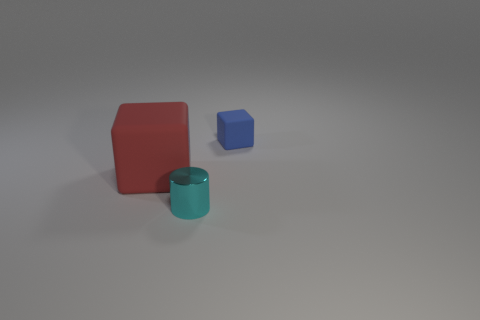Subtract all blue blocks. How many blocks are left? 1 Add 1 tiny cyan objects. How many tiny cyan objects are left? 2 Add 2 blue rubber objects. How many blue rubber objects exist? 3 Add 3 tiny green metallic blocks. How many objects exist? 6 Subtract 0 green blocks. How many objects are left? 3 Subtract all blocks. How many objects are left? 1 Subtract 2 blocks. How many blocks are left? 0 Subtract all yellow cylinders. Subtract all gray balls. How many cylinders are left? 1 Subtract all purple cylinders. How many red blocks are left? 1 Subtract all brown things. Subtract all tiny blue rubber cubes. How many objects are left? 2 